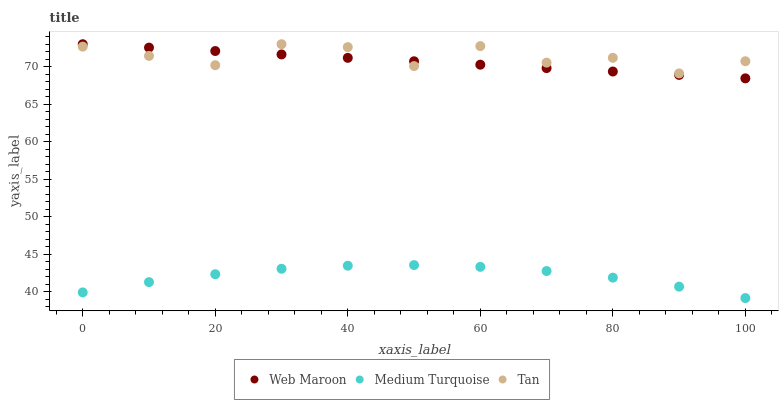Does Medium Turquoise have the minimum area under the curve?
Answer yes or no. Yes. Does Tan have the maximum area under the curve?
Answer yes or no. Yes. Does Web Maroon have the minimum area under the curve?
Answer yes or no. No. Does Web Maroon have the maximum area under the curve?
Answer yes or no. No. Is Web Maroon the smoothest?
Answer yes or no. Yes. Is Tan the roughest?
Answer yes or no. Yes. Is Medium Turquoise the smoothest?
Answer yes or no. No. Is Medium Turquoise the roughest?
Answer yes or no. No. Does Medium Turquoise have the lowest value?
Answer yes or no. Yes. Does Web Maroon have the lowest value?
Answer yes or no. No. Does Web Maroon have the highest value?
Answer yes or no. Yes. Does Medium Turquoise have the highest value?
Answer yes or no. No. Is Medium Turquoise less than Tan?
Answer yes or no. Yes. Is Tan greater than Medium Turquoise?
Answer yes or no. Yes. Does Web Maroon intersect Tan?
Answer yes or no. Yes. Is Web Maroon less than Tan?
Answer yes or no. No. Is Web Maroon greater than Tan?
Answer yes or no. No. Does Medium Turquoise intersect Tan?
Answer yes or no. No. 